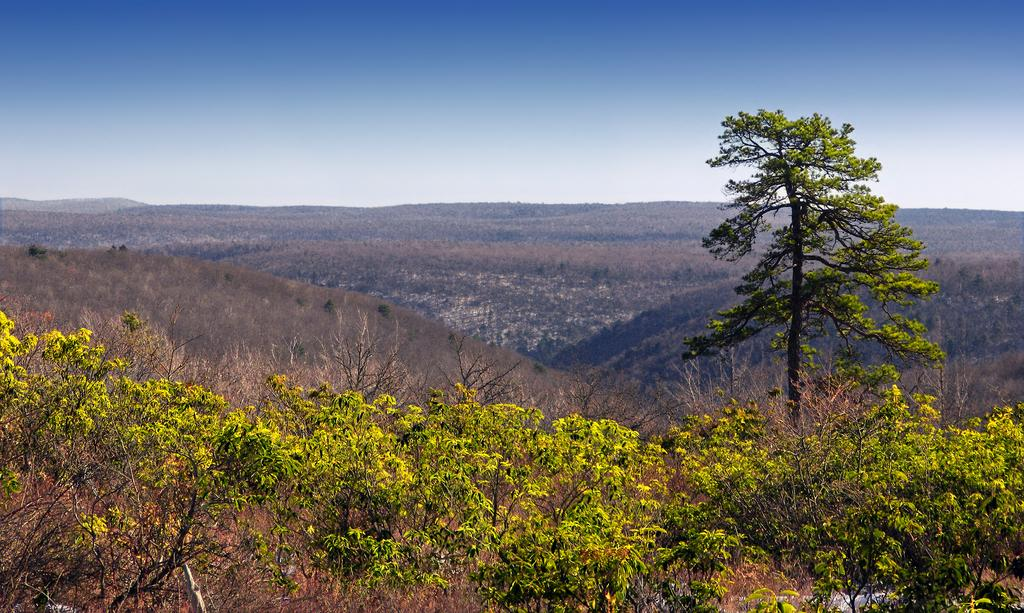What type of vegetation can be seen in the image? There are trees in the image. What geographical feature is visible in the image? There are mountains in the image. What part of the natural environment is visible in the image? The sky is visible in the image. What type of silver brush can be seen in the image? There is no silver brush present in the image. 